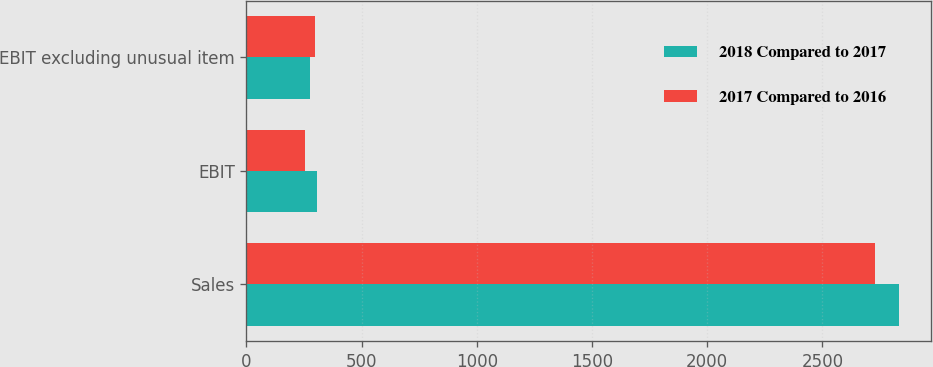<chart> <loc_0><loc_0><loc_500><loc_500><stacked_bar_chart><ecel><fcel>Sales<fcel>EBIT<fcel>EBIT excluding unusual item<nl><fcel>2018 Compared to 2017<fcel>2831<fcel>308<fcel>278<nl><fcel>2017 Compared to 2016<fcel>2728<fcel>255<fcel>299<nl></chart> 